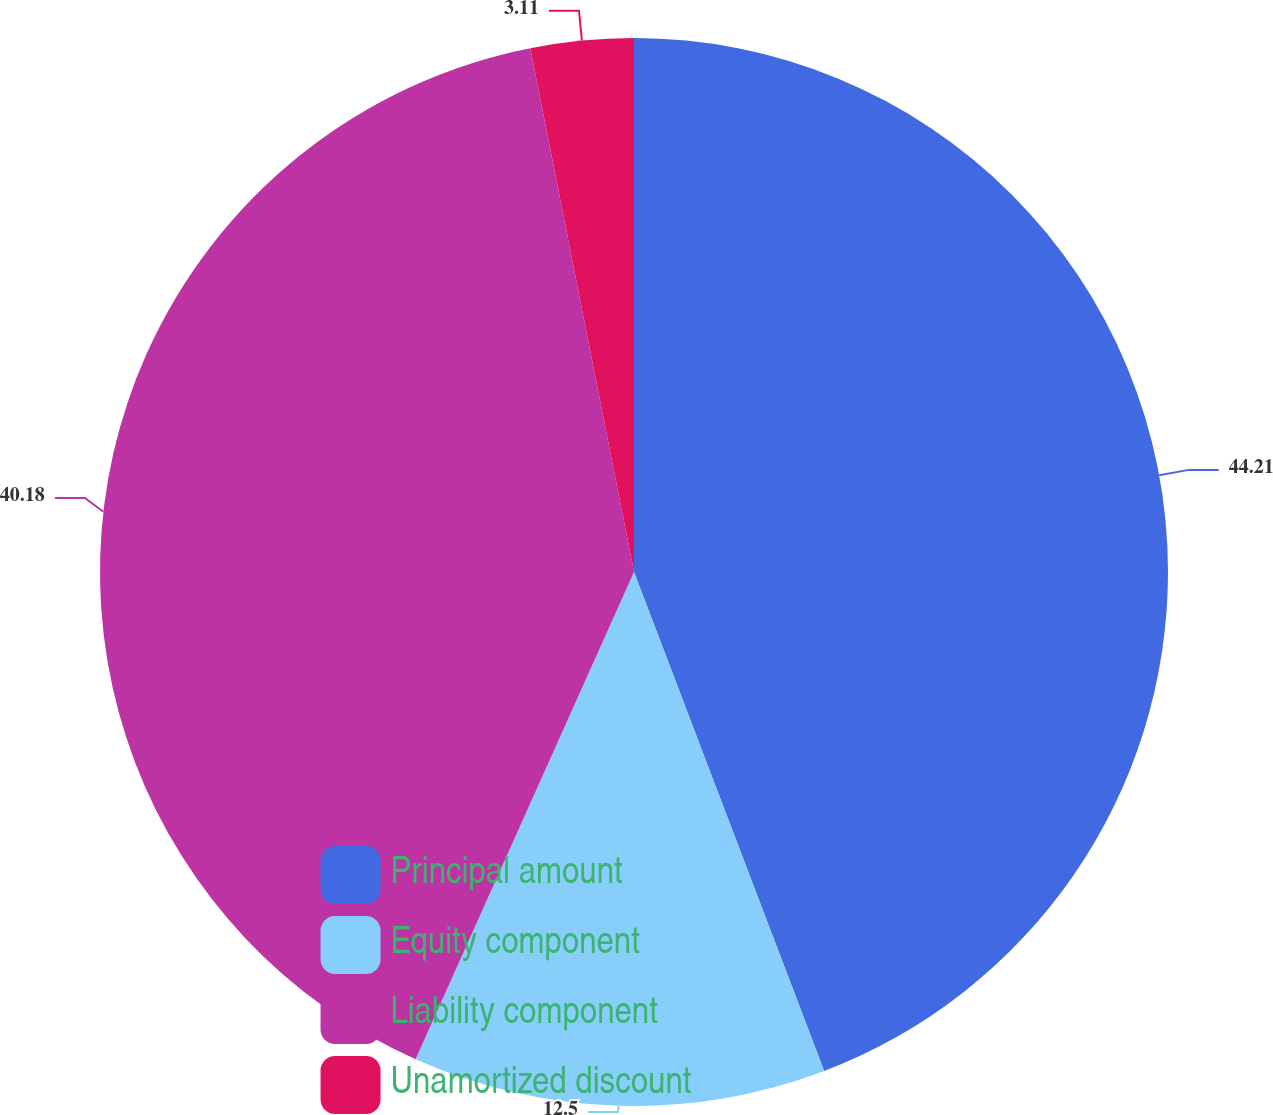Convert chart. <chart><loc_0><loc_0><loc_500><loc_500><pie_chart><fcel>Principal amount<fcel>Equity component<fcel>Liability component<fcel>Unamortized discount<nl><fcel>44.2%<fcel>12.5%<fcel>40.18%<fcel>3.11%<nl></chart> 